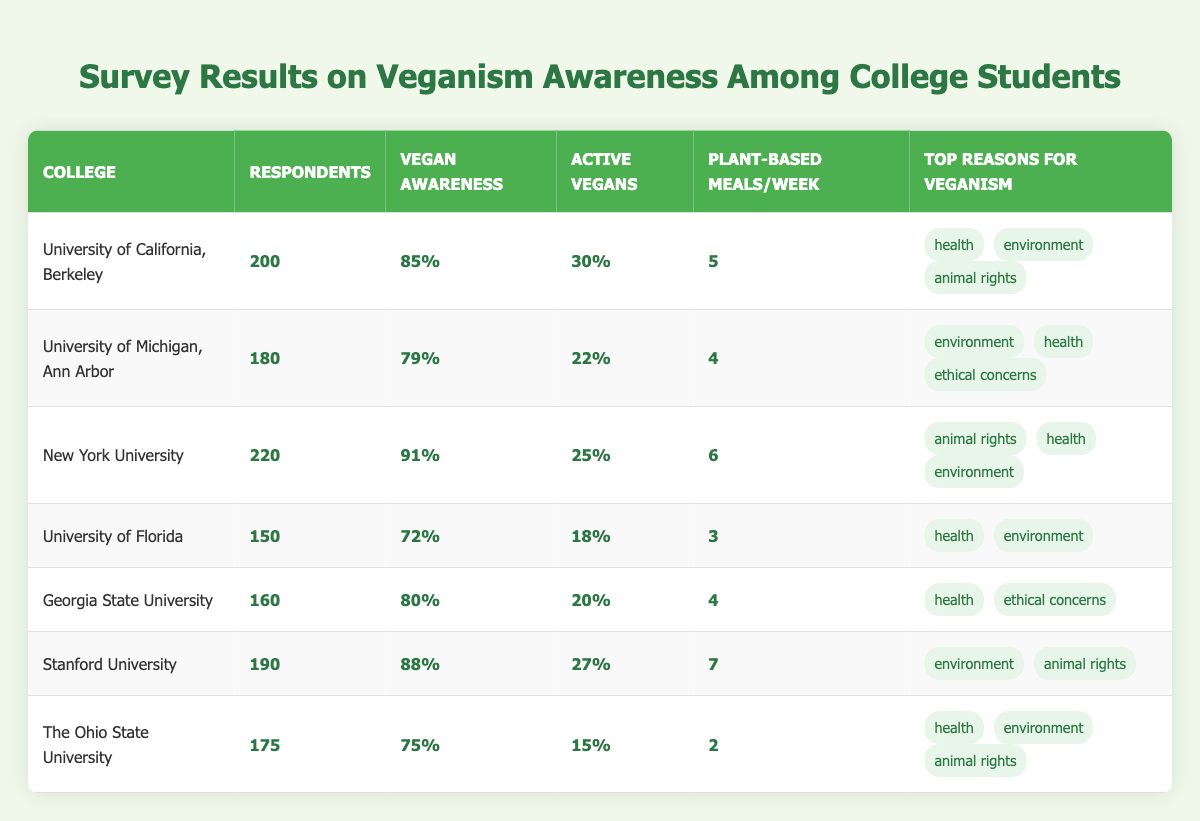What percentage of respondents at New York University are aware of veganism? The table shows that New York University has a vegan awareness percentage of **91%** based on the data provided.
Answer: 91% Which college has the highest percentage of active vegans? By examining the active vegans percentages, University of California, Berkeley has **30%**, which is the highest among the listed colleges.
Answer: University of California, Berkeley What is the average number of plant-based meals per week across all colleges? The number of plant-based meals per week are **5, 4, 6, 3, 4, 7, and 2**. Adding them gives **31** and dividing by **7** results in an average of approximately **4.43**.
Answer: 4.43 Which colleges have a vegan awareness percentage below 80%? The institutions with vegan awareness percentages below 80% are **University of Florida** (72%) and **The Ohio State University** (75%).
Answer: University of Florida, The Ohio State University Is it true that Georgia State University has more active vegans than the University of Florida? Georgia State University has **20%** active vegans while University of Florida has **18%**, thus it is true that Georgia State University has more.
Answer: True What is the total number of respondents from colleges with a vegan awareness percentage greater than or equal to 85%? The colleges with awareness percentage greater than or equal to 85% are University of California, Berkeley (**200**), New York University (**220**), and Stanford University (**190**). Adding these gives **610**.
Answer: 610 How many colleges cited "animal rights" as a top reason for veganism? From the table, **4** colleges mentioned "animal rights" as a reason: University of California, Berkeley, New York University, Stanford University, and The Ohio State University.
Answer: 4 What percentage of respondents at the University of Michigan, Ann Arbor are students who follow a vegan diet? The table shows that University of Michigan, Ann Arbor has **22%** of its respondents identified as active vegans.
Answer: 22% If you consider the plant-based meals per week, which college has the highest average? The plant-based meals per week are **5** (UC Berkeley), **4** (Michigan), **6** (NYU), **3** (Florida), **4** (Georgia State), **7** (Stanford), **2** (Ohio State). The maximum is **7** from Stanford University.
Answer: Stanford University Which colleges equally emphasize health as a reason for veganism? The colleges that listed health as a top reason for veganism are University of California, Berkeley, University of Florida, Georgia State University, and New York University. Georgia State and University of Florida both emphasize it.
Answer: 3 